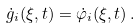<formula> <loc_0><loc_0><loc_500><loc_500>\dot { g } _ { i } ( \xi , t ) = \dot { \varphi } _ { i } ( \xi , t ) \, .</formula> 